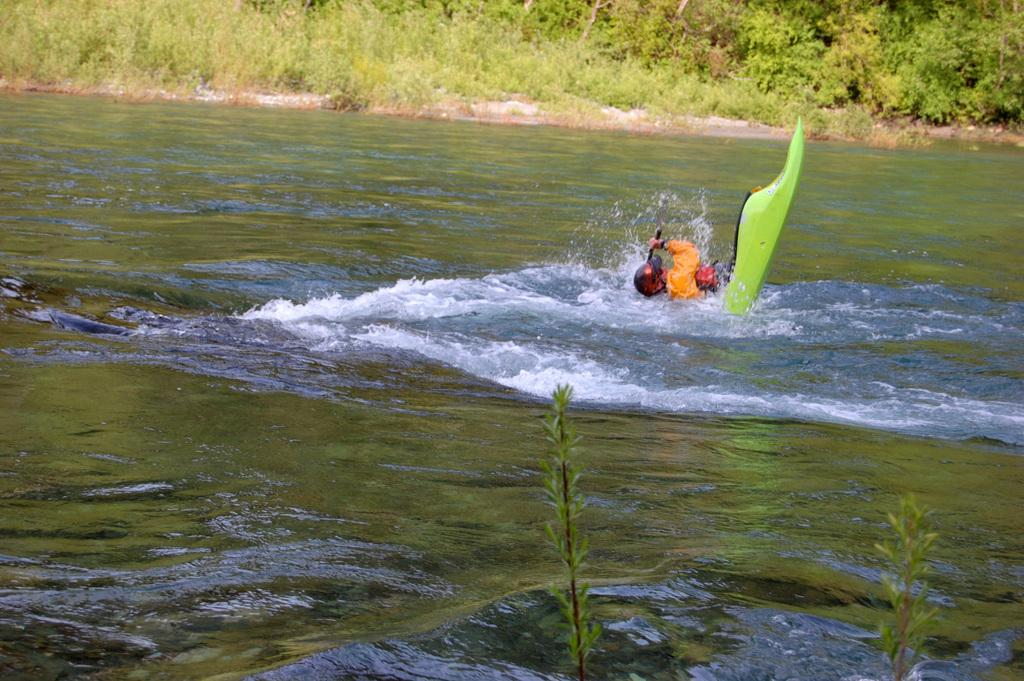Who or what is the main subject in the image? There is a person in the image. What is the person doing in the image? The person is on a surfboard. Where is the surfboard located? The surfboard is on water. What can be seen in the background of the image? There are trees in the background of the image. Can you tell me how many monkeys are sitting on the surfboard in the image? There are no monkeys present in the image; the person is the only subject on the surfboard. 